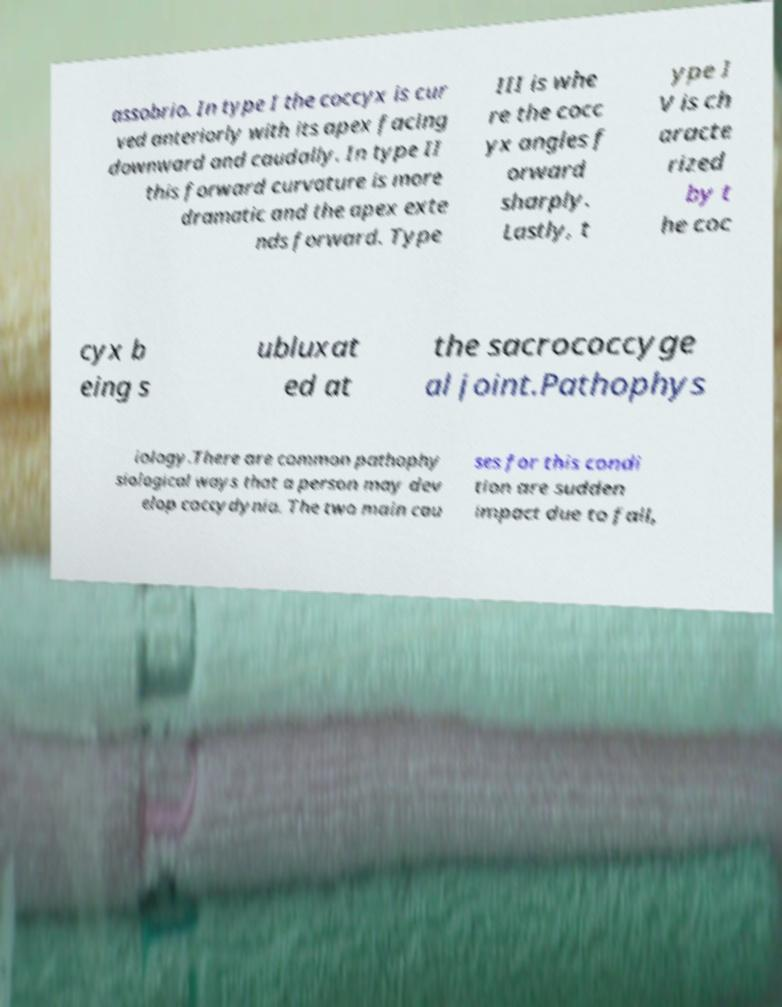Please identify and transcribe the text found in this image. assobrio. In type I the coccyx is cur ved anteriorly with its apex facing downward and caudally. In type II this forward curvature is more dramatic and the apex exte nds forward. Type III is whe re the cocc yx angles f orward sharply. Lastly, t ype I V is ch aracte rized by t he coc cyx b eing s ubluxat ed at the sacrococcyge al joint.Pathophys iology.There are common pathophy siological ways that a person may dev elop coccydynia. The two main cau ses for this condi tion are sudden impact due to fall, 